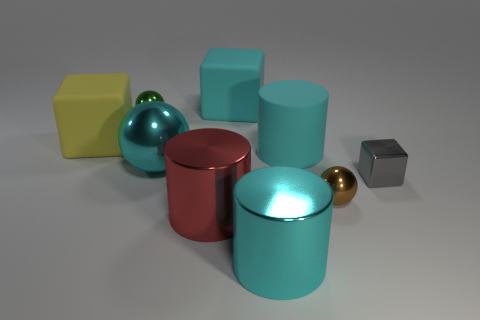There is a small green shiny thing left of the large cyan thing in front of the large red object; is there a tiny green metal sphere on the right side of it?
Give a very brief answer. No. Are the large cyan thing that is in front of the brown metal sphere and the brown ball that is in front of the green object made of the same material?
Give a very brief answer. Yes. What number of objects are blue metallic balls or big cyan cylinders behind the gray object?
Your response must be concise. 1. What number of other big things have the same shape as the yellow thing?
Your response must be concise. 1. What material is the cyan cube that is the same size as the red cylinder?
Provide a short and direct response. Rubber. There is a green shiny ball that is behind the large matte object that is left of the large block that is on the right side of the red cylinder; what is its size?
Keep it short and to the point. Small. Does the thing behind the tiny green metallic ball have the same color as the big matte object that is on the left side of the tiny green object?
Offer a terse response. No. What number of gray things are cylinders or small shiny cubes?
Provide a short and direct response. 1. What number of yellow rubber blocks are the same size as the green shiny sphere?
Ensure brevity in your answer.  0. Is the large block behind the yellow rubber block made of the same material as the green thing?
Your answer should be compact. No. 